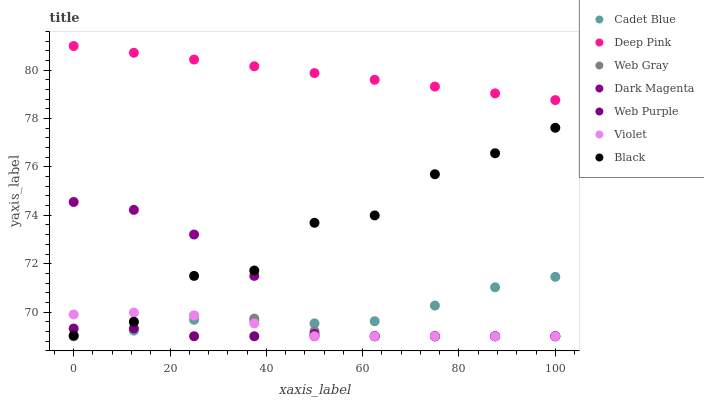Does Web Purple have the minimum area under the curve?
Answer yes or no. Yes. Does Deep Pink have the maximum area under the curve?
Answer yes or no. Yes. Does Dark Magenta have the minimum area under the curve?
Answer yes or no. No. Does Dark Magenta have the maximum area under the curve?
Answer yes or no. No. Is Deep Pink the smoothest?
Answer yes or no. Yes. Is Black the roughest?
Answer yes or no. Yes. Is Dark Magenta the smoothest?
Answer yes or no. No. Is Dark Magenta the roughest?
Answer yes or no. No. Does Cadet Blue have the lowest value?
Answer yes or no. Yes. Does Deep Pink have the lowest value?
Answer yes or no. No. Does Deep Pink have the highest value?
Answer yes or no. Yes. Does Dark Magenta have the highest value?
Answer yes or no. No. Is Web Purple less than Deep Pink?
Answer yes or no. Yes. Is Black greater than Cadet Blue?
Answer yes or no. Yes. Does Violet intersect Cadet Blue?
Answer yes or no. Yes. Is Violet less than Cadet Blue?
Answer yes or no. No. Is Violet greater than Cadet Blue?
Answer yes or no. No. Does Web Purple intersect Deep Pink?
Answer yes or no. No. 